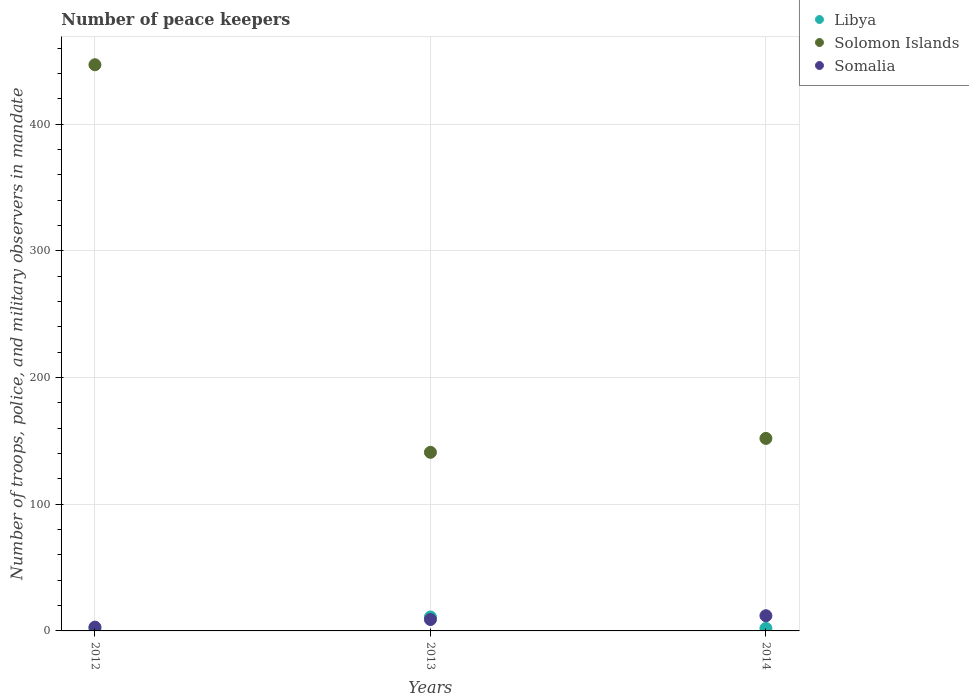How many different coloured dotlines are there?
Offer a very short reply. 3. Is the number of dotlines equal to the number of legend labels?
Your answer should be compact. Yes. In which year was the number of peace keepers in in Libya maximum?
Provide a short and direct response. 2013. In which year was the number of peace keepers in in Solomon Islands minimum?
Make the answer very short. 2013. What is the total number of peace keepers in in Somalia in the graph?
Provide a short and direct response. 24. What is the difference between the number of peace keepers in in Libya in 2013 and the number of peace keepers in in Somalia in 2012?
Keep it short and to the point. 8. What is the average number of peace keepers in in Solomon Islands per year?
Your answer should be compact. 246.67. In the year 2014, what is the difference between the number of peace keepers in in Libya and number of peace keepers in in Somalia?
Ensure brevity in your answer.  -10. In how many years, is the number of peace keepers in in Somalia greater than 200?
Make the answer very short. 0. What is the ratio of the number of peace keepers in in Libya in 2013 to that in 2014?
Ensure brevity in your answer.  5.5. Is the number of peace keepers in in Solomon Islands in 2013 less than that in 2014?
Your answer should be very brief. Yes. Is the difference between the number of peace keepers in in Libya in 2012 and 2014 greater than the difference between the number of peace keepers in in Somalia in 2012 and 2014?
Your answer should be compact. Yes. What is the difference between the highest and the second highest number of peace keepers in in Solomon Islands?
Your response must be concise. 295. What is the difference between the highest and the lowest number of peace keepers in in Solomon Islands?
Offer a very short reply. 306. In how many years, is the number of peace keepers in in Somalia greater than the average number of peace keepers in in Somalia taken over all years?
Keep it short and to the point. 2. Is it the case that in every year, the sum of the number of peace keepers in in Solomon Islands and number of peace keepers in in Libya  is greater than the number of peace keepers in in Somalia?
Provide a succinct answer. Yes. Is the number of peace keepers in in Solomon Islands strictly greater than the number of peace keepers in in Libya over the years?
Your response must be concise. Yes. Is the number of peace keepers in in Libya strictly less than the number of peace keepers in in Solomon Islands over the years?
Offer a terse response. Yes. How many dotlines are there?
Make the answer very short. 3. What is the difference between two consecutive major ticks on the Y-axis?
Provide a short and direct response. 100. Does the graph contain any zero values?
Offer a terse response. No. Does the graph contain grids?
Keep it short and to the point. Yes. Where does the legend appear in the graph?
Offer a very short reply. Top right. How many legend labels are there?
Ensure brevity in your answer.  3. How are the legend labels stacked?
Your answer should be very brief. Vertical. What is the title of the graph?
Your answer should be compact. Number of peace keepers. What is the label or title of the Y-axis?
Offer a very short reply. Number of troops, police, and military observers in mandate. What is the Number of troops, police, and military observers in mandate of Libya in 2012?
Provide a succinct answer. 2. What is the Number of troops, police, and military observers in mandate of Solomon Islands in 2012?
Provide a succinct answer. 447. What is the Number of troops, police, and military observers in mandate in Libya in 2013?
Provide a succinct answer. 11. What is the Number of troops, police, and military observers in mandate in Solomon Islands in 2013?
Provide a short and direct response. 141. What is the Number of troops, police, and military observers in mandate of Somalia in 2013?
Offer a terse response. 9. What is the Number of troops, police, and military observers in mandate of Solomon Islands in 2014?
Offer a terse response. 152. What is the Number of troops, police, and military observers in mandate of Somalia in 2014?
Make the answer very short. 12. Across all years, what is the maximum Number of troops, police, and military observers in mandate in Libya?
Keep it short and to the point. 11. Across all years, what is the maximum Number of troops, police, and military observers in mandate of Solomon Islands?
Keep it short and to the point. 447. Across all years, what is the minimum Number of troops, police, and military observers in mandate in Libya?
Provide a short and direct response. 2. Across all years, what is the minimum Number of troops, police, and military observers in mandate in Solomon Islands?
Provide a short and direct response. 141. Across all years, what is the minimum Number of troops, police, and military observers in mandate of Somalia?
Your answer should be compact. 3. What is the total Number of troops, police, and military observers in mandate in Solomon Islands in the graph?
Keep it short and to the point. 740. What is the difference between the Number of troops, police, and military observers in mandate in Solomon Islands in 2012 and that in 2013?
Ensure brevity in your answer.  306. What is the difference between the Number of troops, police, and military observers in mandate of Somalia in 2012 and that in 2013?
Give a very brief answer. -6. What is the difference between the Number of troops, police, and military observers in mandate of Libya in 2012 and that in 2014?
Give a very brief answer. 0. What is the difference between the Number of troops, police, and military observers in mandate in Solomon Islands in 2012 and that in 2014?
Your answer should be very brief. 295. What is the difference between the Number of troops, police, and military observers in mandate in Libya in 2013 and that in 2014?
Your response must be concise. 9. What is the difference between the Number of troops, police, and military observers in mandate in Libya in 2012 and the Number of troops, police, and military observers in mandate in Solomon Islands in 2013?
Ensure brevity in your answer.  -139. What is the difference between the Number of troops, police, and military observers in mandate in Libya in 2012 and the Number of troops, police, and military observers in mandate in Somalia in 2013?
Your response must be concise. -7. What is the difference between the Number of troops, police, and military observers in mandate in Solomon Islands in 2012 and the Number of troops, police, and military observers in mandate in Somalia in 2013?
Provide a short and direct response. 438. What is the difference between the Number of troops, police, and military observers in mandate in Libya in 2012 and the Number of troops, police, and military observers in mandate in Solomon Islands in 2014?
Give a very brief answer. -150. What is the difference between the Number of troops, police, and military observers in mandate of Libya in 2012 and the Number of troops, police, and military observers in mandate of Somalia in 2014?
Your response must be concise. -10. What is the difference between the Number of troops, police, and military observers in mandate of Solomon Islands in 2012 and the Number of troops, police, and military observers in mandate of Somalia in 2014?
Provide a short and direct response. 435. What is the difference between the Number of troops, police, and military observers in mandate of Libya in 2013 and the Number of troops, police, and military observers in mandate of Solomon Islands in 2014?
Ensure brevity in your answer.  -141. What is the difference between the Number of troops, police, and military observers in mandate of Solomon Islands in 2013 and the Number of troops, police, and military observers in mandate of Somalia in 2014?
Give a very brief answer. 129. What is the average Number of troops, police, and military observers in mandate of Solomon Islands per year?
Keep it short and to the point. 246.67. In the year 2012, what is the difference between the Number of troops, police, and military observers in mandate of Libya and Number of troops, police, and military observers in mandate of Solomon Islands?
Give a very brief answer. -445. In the year 2012, what is the difference between the Number of troops, police, and military observers in mandate in Libya and Number of troops, police, and military observers in mandate in Somalia?
Your response must be concise. -1. In the year 2012, what is the difference between the Number of troops, police, and military observers in mandate in Solomon Islands and Number of troops, police, and military observers in mandate in Somalia?
Your answer should be compact. 444. In the year 2013, what is the difference between the Number of troops, police, and military observers in mandate of Libya and Number of troops, police, and military observers in mandate of Solomon Islands?
Your answer should be compact. -130. In the year 2013, what is the difference between the Number of troops, police, and military observers in mandate in Solomon Islands and Number of troops, police, and military observers in mandate in Somalia?
Your response must be concise. 132. In the year 2014, what is the difference between the Number of troops, police, and military observers in mandate in Libya and Number of troops, police, and military observers in mandate in Solomon Islands?
Offer a terse response. -150. In the year 2014, what is the difference between the Number of troops, police, and military observers in mandate of Solomon Islands and Number of troops, police, and military observers in mandate of Somalia?
Your answer should be compact. 140. What is the ratio of the Number of troops, police, and military observers in mandate of Libya in 2012 to that in 2013?
Your answer should be very brief. 0.18. What is the ratio of the Number of troops, police, and military observers in mandate in Solomon Islands in 2012 to that in 2013?
Your response must be concise. 3.17. What is the ratio of the Number of troops, police, and military observers in mandate of Solomon Islands in 2012 to that in 2014?
Offer a very short reply. 2.94. What is the ratio of the Number of troops, police, and military observers in mandate of Somalia in 2012 to that in 2014?
Make the answer very short. 0.25. What is the ratio of the Number of troops, police, and military observers in mandate of Solomon Islands in 2013 to that in 2014?
Your answer should be compact. 0.93. What is the ratio of the Number of troops, police, and military observers in mandate of Somalia in 2013 to that in 2014?
Your answer should be compact. 0.75. What is the difference between the highest and the second highest Number of troops, police, and military observers in mandate of Solomon Islands?
Ensure brevity in your answer.  295. What is the difference between the highest and the second highest Number of troops, police, and military observers in mandate of Somalia?
Make the answer very short. 3. What is the difference between the highest and the lowest Number of troops, police, and military observers in mandate of Solomon Islands?
Give a very brief answer. 306. What is the difference between the highest and the lowest Number of troops, police, and military observers in mandate of Somalia?
Offer a very short reply. 9. 